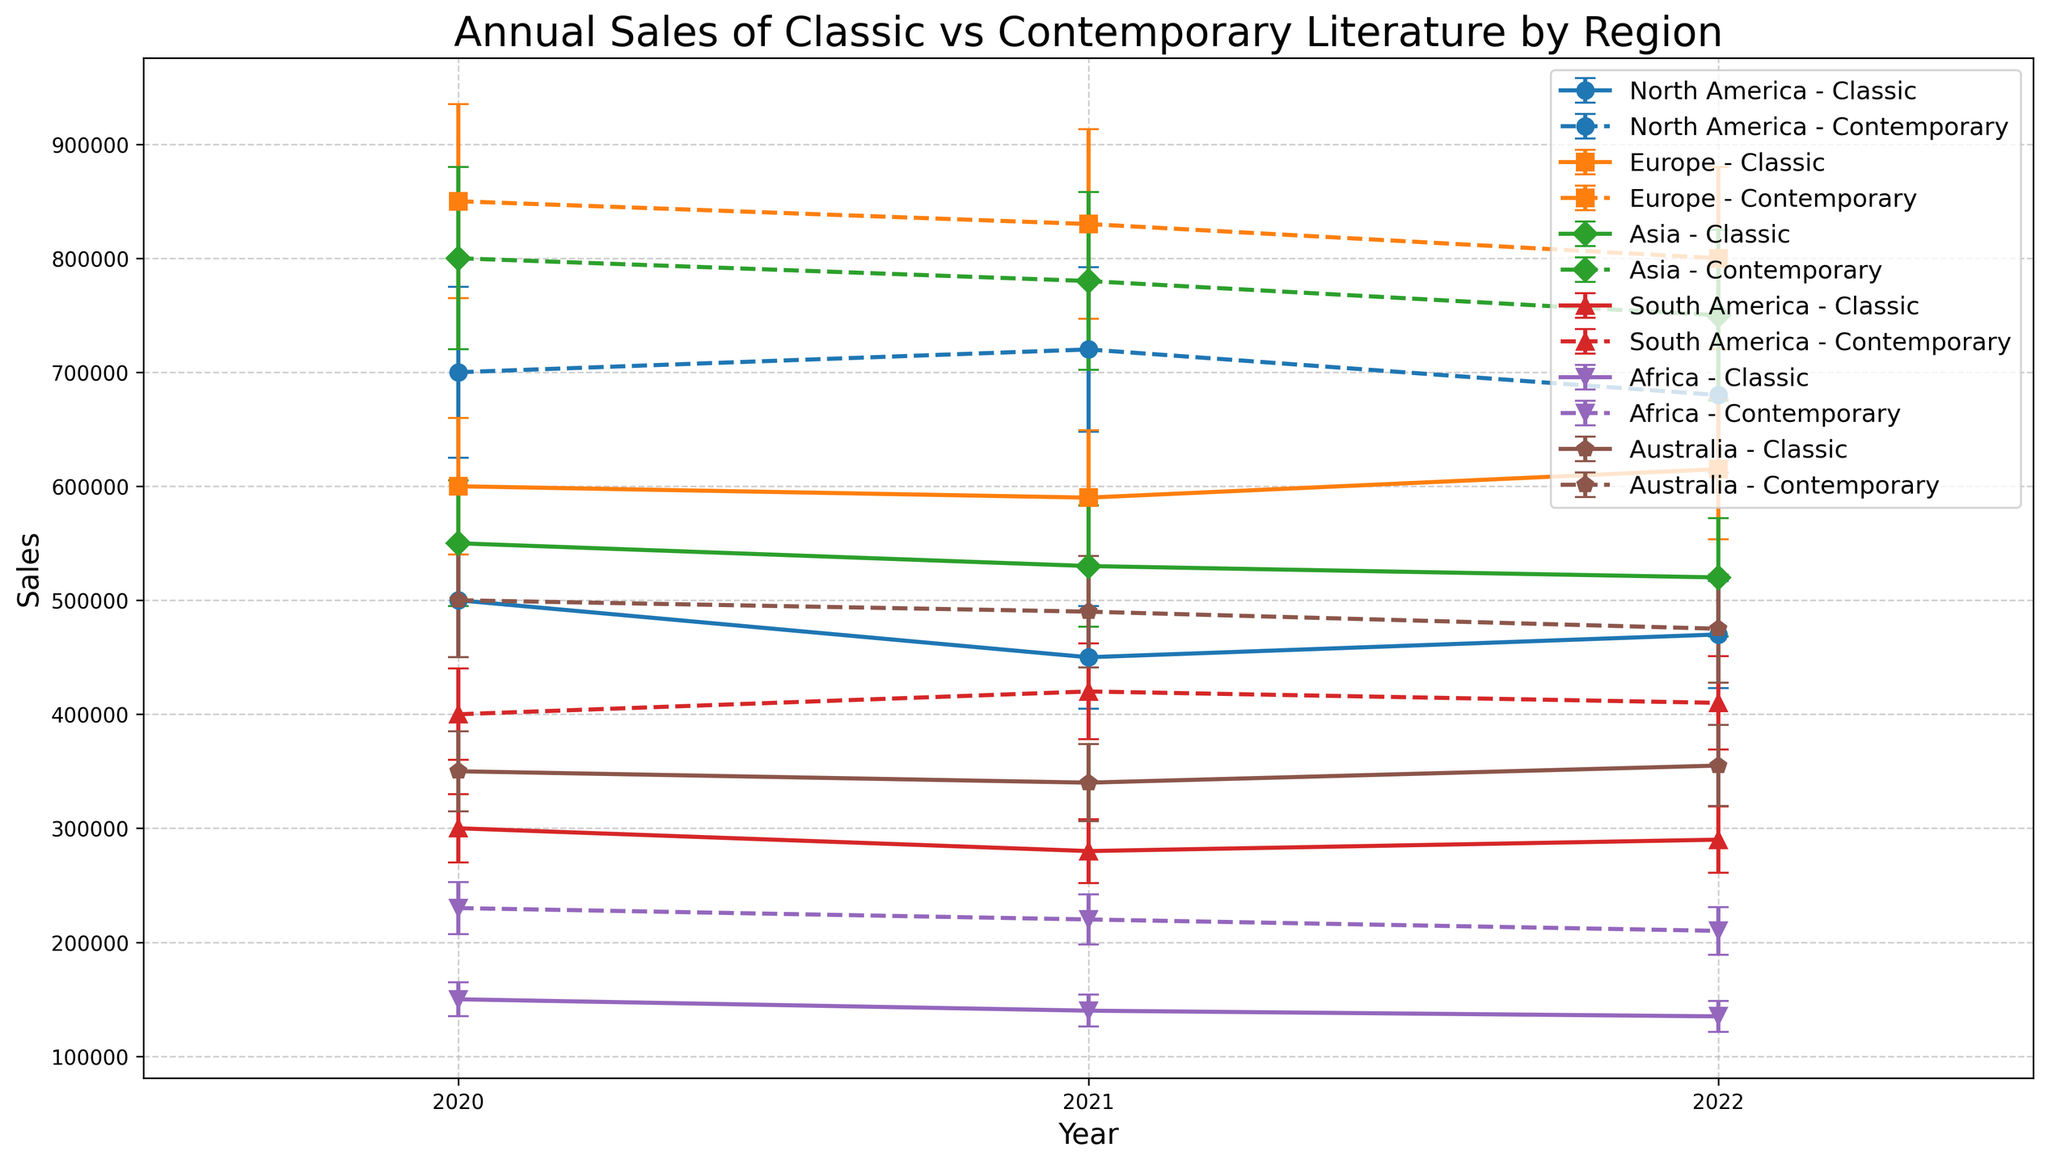What's the trend in the sales of classic literature in North America from 2020 to 2022? To determine the trend, observe the classic literature sales for North America over the years 2020, 2021, and 2022. In 2020, sales were 470,000; in 2021, sales were 450,000; and in 2022, sales were 500,000. The sales decreased from 2020 to 2021 and then increased from 2021 to 2022.
Answer: Decreasing then increasing Which region shows the smallest difference between classic and contemporary literature sales in 2022? Compare the differences between classic and contemporary literature sales for each region in 2022. The differences are: North America (200,000), Europe (250,000), Asia (250,000), South America (100,000), Africa (80,000), and Australia (150,000). Africa has the smallest difference.
Answer: Africa Compare the contemporary literature sales in Europe and Asia in 2020. Which region had higher sales? Check the contemporary literature sales figures for Europe and Asia in 2020. Europe had sales of 800,000, and Asia had sales of 750,000. Europe had higher sales.
Answer: Europe What is the average sales of contemporary literature in South America over the three years? Add up the contemporary literature sales for South America from 2020 to 2022 and divide by the number of years. The sum is 410,000 + 420,000 + 400,000 = 1,230,000. The average is 1,230,000 / 3.
Answer: 410,000 In which region did classic literature sales remain fairly stable over 2020-2022? Assess the stability of classic literature sales for each region over the years. Australia’s classic literature sales were 355,000 in 2020, 340,000 in 2021, and 350,000 in 2022, showing the least fluctuation.
Answer: Australia Which region experienced the highest contemporary literature sales in 2022, and what was the value? Check the contemporary literature sales across all regions in 2022. Europe had the highest sales with 850,000.
Answer: Europe; 850,000 Compare the error bars for contemporary literature sales in Asia and South America in 2021. Which region had larger variability, and how does it visually manifest on the plot? Examine the heights of the error bars for contemporary literature sales in Asia and South America in 2021. Asia's error bar is 78,000, whereas South America's is 42,000. Longer error bars indicate larger variability; hence Asia shows greater variability.
Answer: Asia What is the difference in classic literature sales between Africa and Europe in 2022? Subtract Africa's classic literature sales in 2022 from Europe's in the same year. Europe had 600,000 sales, and Africa had 150,000. The difference is 600,000 - 150,000.
Answer: 450,000 In 2022, how many regions had contemporary literature sales that surpassed 500,000, and which regions were they? Identify regions where contemporary literature sales in 2022 exceeded 500,000. Europe (850,000), Asia (800,000), and North America (700,000) are the regions. The count is three.
Answer: 3; Europe, Asia, North America Which region shows an increasing trend in both classic and contemporary literature sales from 2020 to 2022? Observe the sales trends in both categories for all regions. Asia’s sales increased in both categories: classic sales from 520,000 to 550,000 and contemporary sales from 750,000 to 800,000.
Answer: Asia 